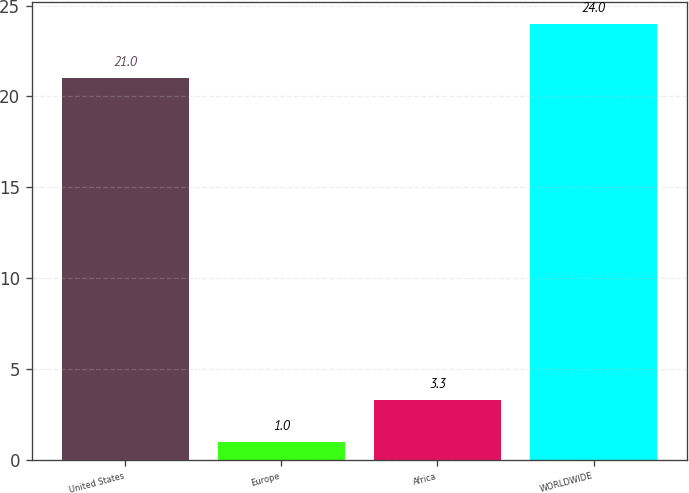Convert chart to OTSL. <chart><loc_0><loc_0><loc_500><loc_500><bar_chart><fcel>United States<fcel>Europe<fcel>Africa<fcel>WORLDWIDE<nl><fcel>21<fcel>1<fcel>3.3<fcel>24<nl></chart> 